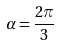<formula> <loc_0><loc_0><loc_500><loc_500>\alpha = { \frac { 2 \pi } { 3 } }</formula> 